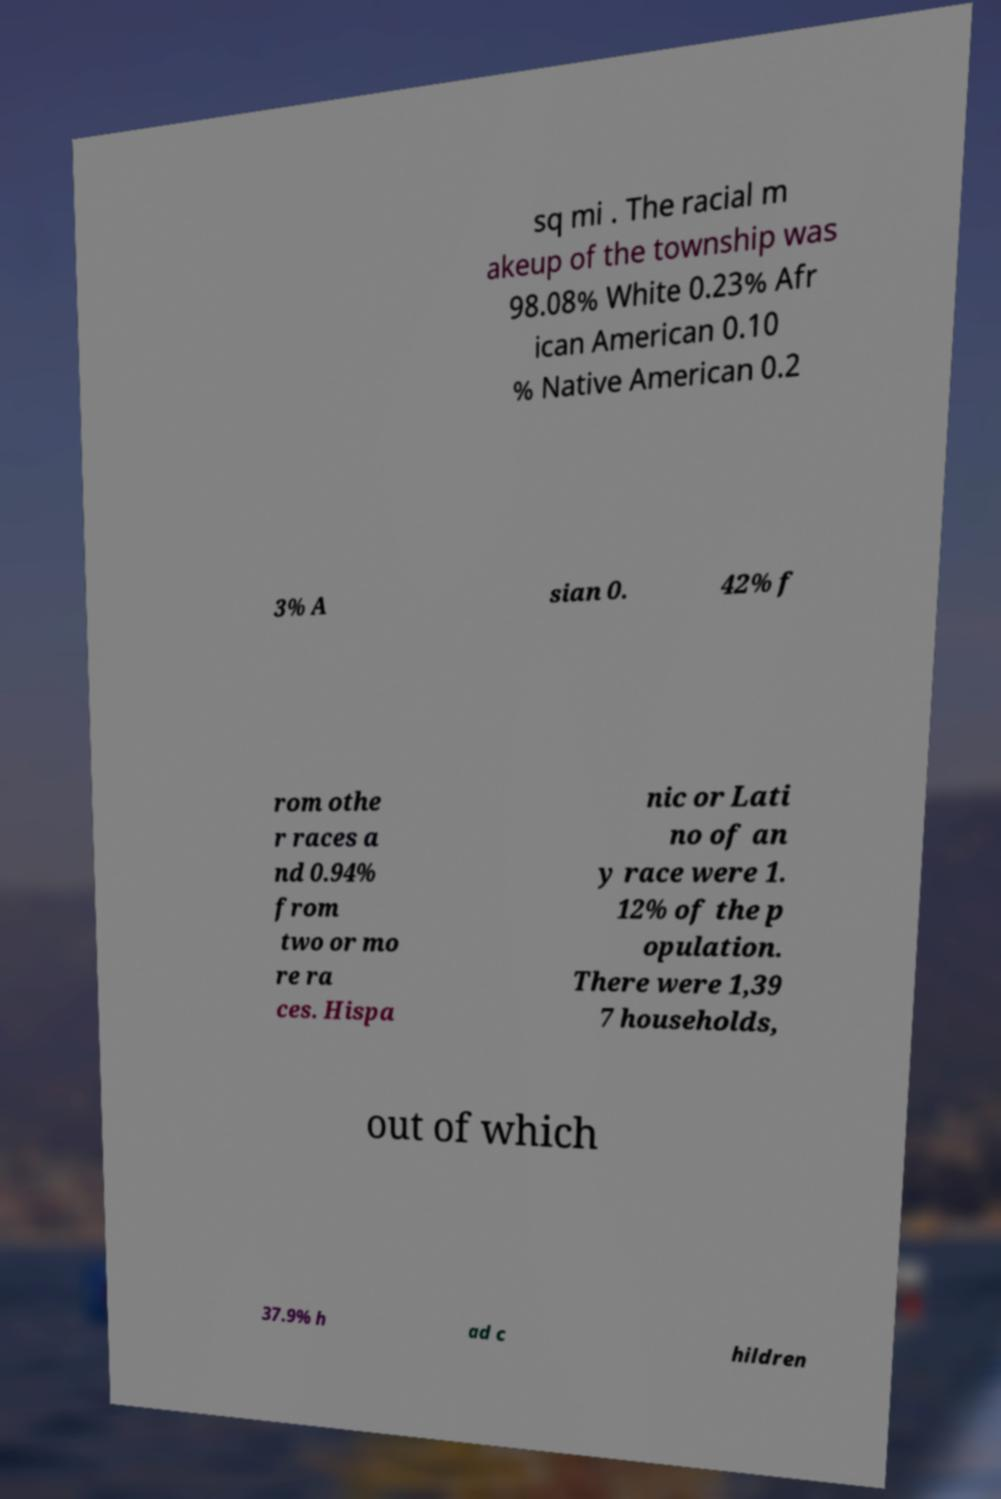Please identify and transcribe the text found in this image. sq mi . The racial m akeup of the township was 98.08% White 0.23% Afr ican American 0.10 % Native American 0.2 3% A sian 0. 42% f rom othe r races a nd 0.94% from two or mo re ra ces. Hispa nic or Lati no of an y race were 1. 12% of the p opulation. There were 1,39 7 households, out of which 37.9% h ad c hildren 